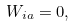<formula> <loc_0><loc_0><loc_500><loc_500>W _ { i a } = 0 ,</formula> 